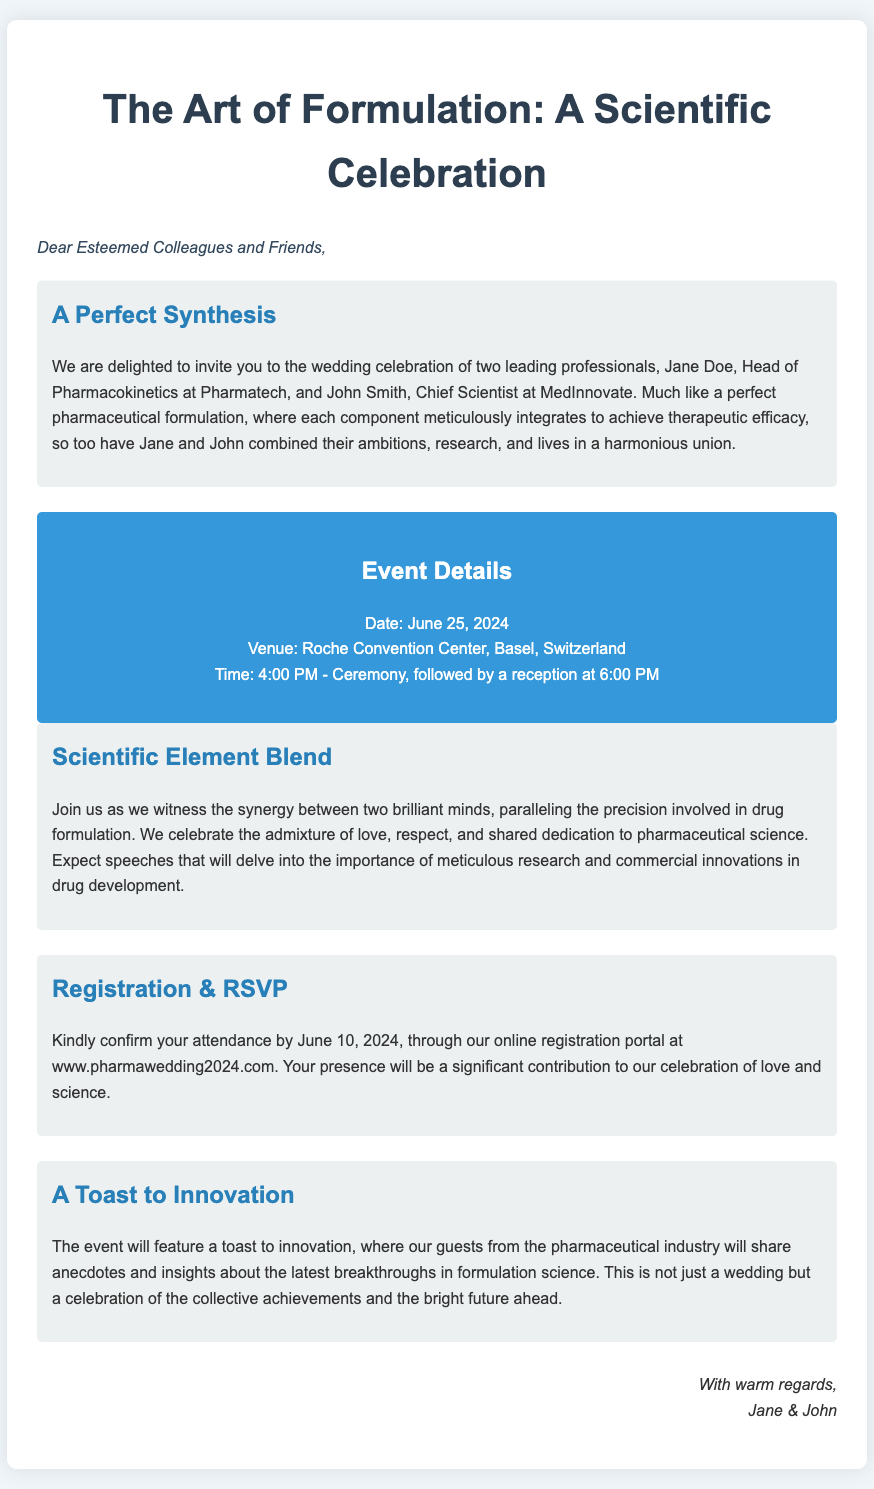What are the names of the couple? The names of the couple are mentioned in the introduction section as Jane Doe and John Smith.
Answer: Jane Doe and John Smith What is the date of the wedding? The date of the wedding is specified in the event details section.
Answer: June 25, 2024 Where will the ceremony take place? The venue for the ceremony is provided in the event details section.
Answer: Roche Convention Center, Basel, Switzerland What time does the ceremony start? The start time for the ceremony is listed in the event details section.
Answer: 4:00 PM What is the RSVP deadline? The registration and RSVP deadline is clearly mentioned in the registration section.
Answer: June 10, 2024 What thematic parallels are drawn in the invitation? The invitation draws parallels between the marriage and drug formulation in the scientific element blend section.
Answer: Pharmaceutical formulation What type of guests are expected to attend? The type of guests mentioned in the context of the event is provided in the toast to innovation section.
Answer: Guests from the pharmaceutical industry What will be discussed during the event? The content of discussions is highlighted in the scientific element blend section and the toast to innovation section.
Answer: Breakthroughs in formulation science What is the primary purpose of the event? The primary purpose is outlined in the introduction and throughout the invitation.
Answer: Celebration of love and science 